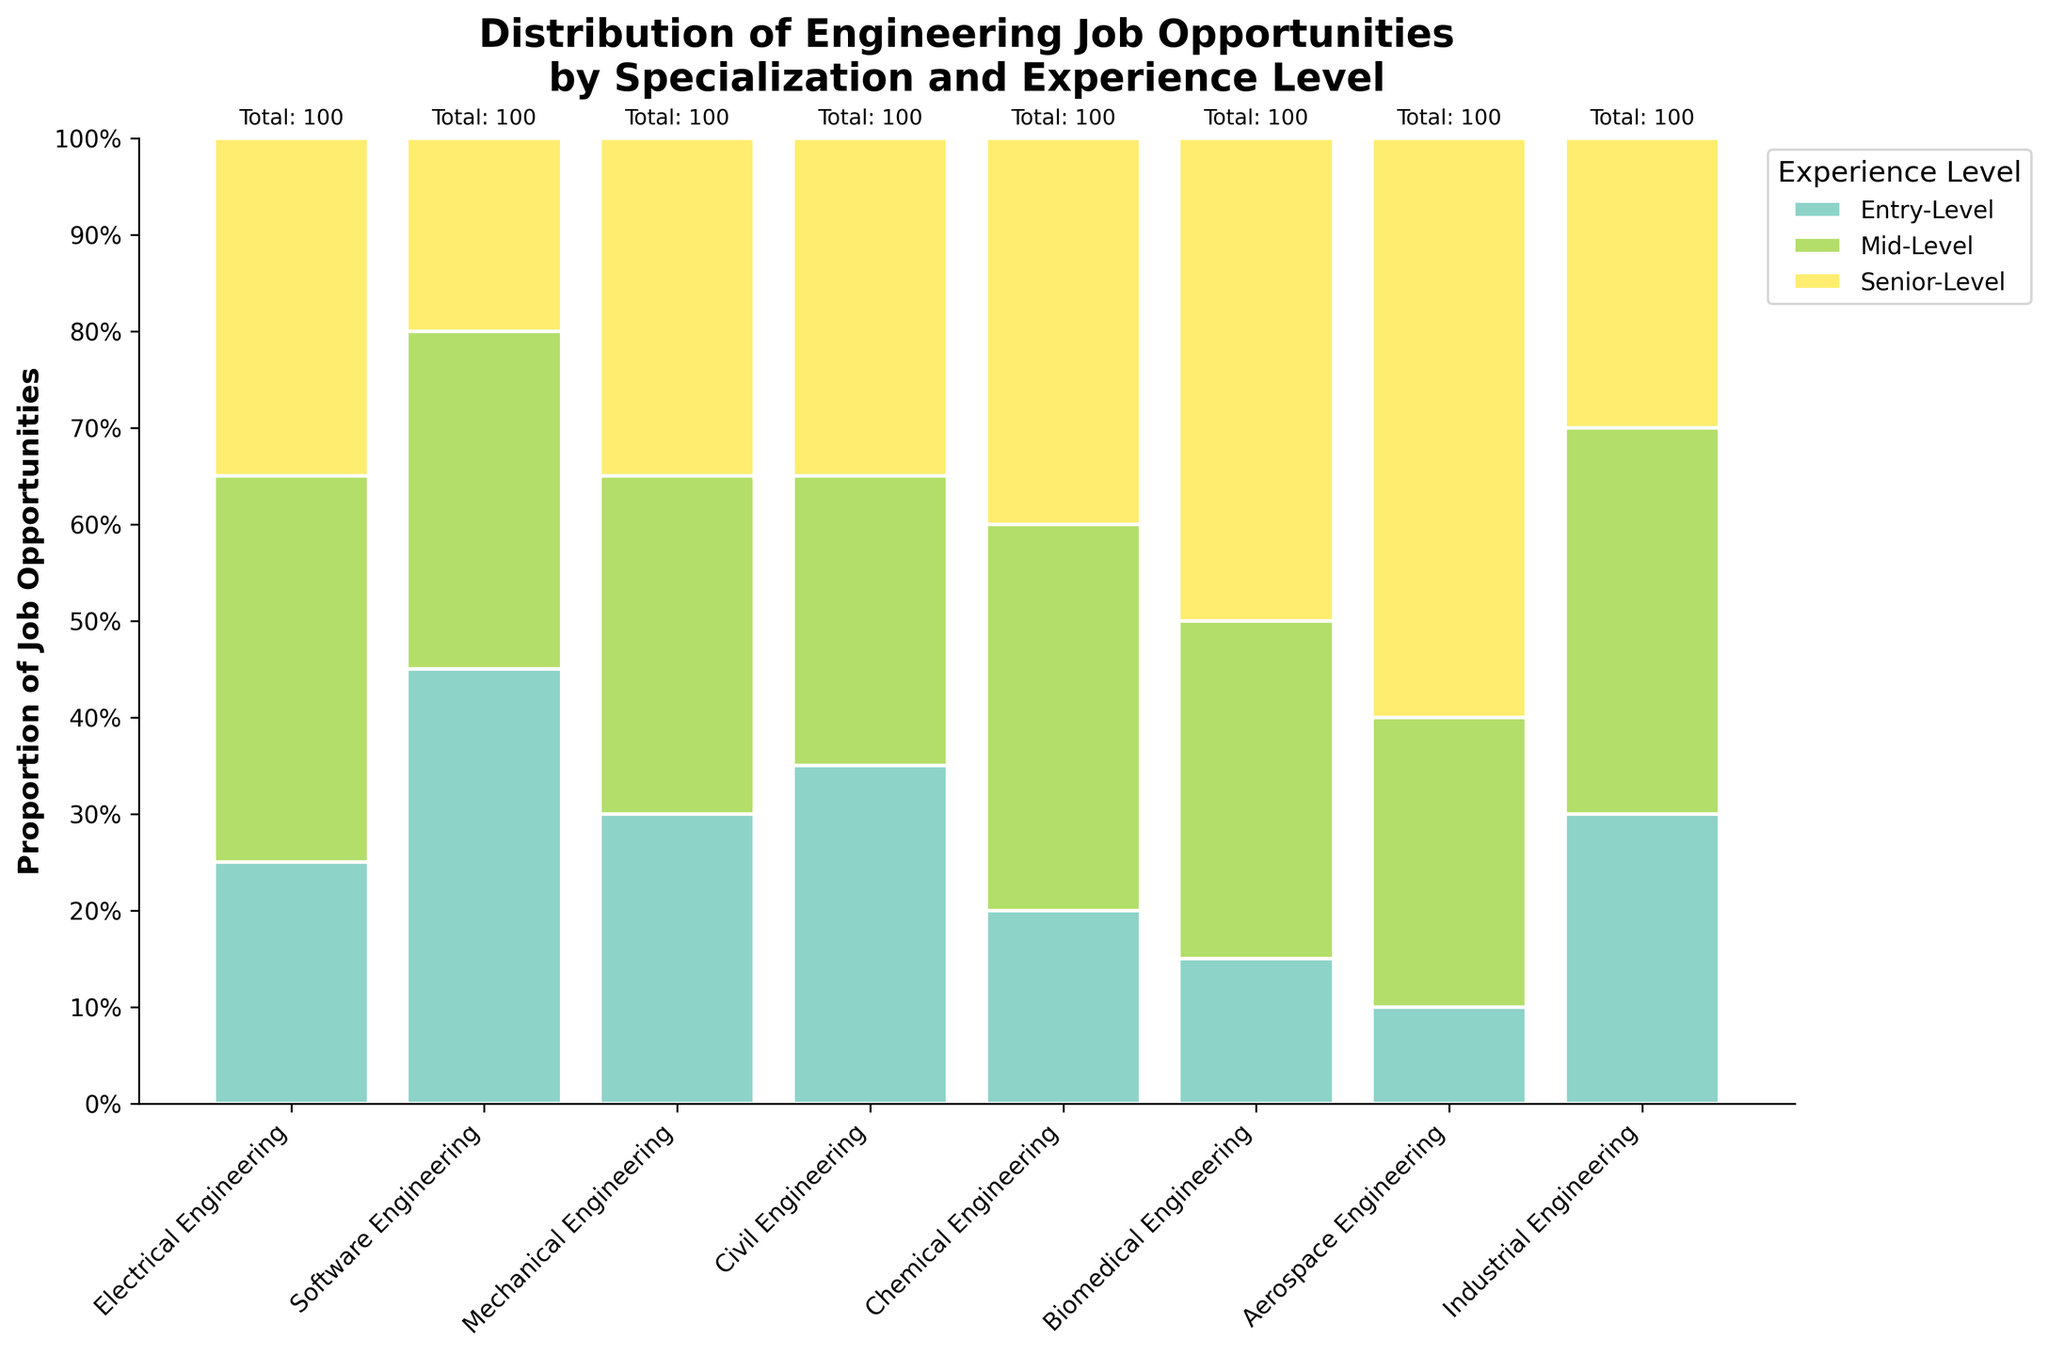What is the title of the figure? The title of a figure is usually located at the top. In this case, it says "Distribution of Engineering Job Opportunities by Specialization and Experience Level" in a large, bold font.
Answer: Distribution of Engineering Job Opportunities by Specialization and Experience Level What does the y-axis represent? The y-axis label is "Proportion of Job Opportunities," indicating that the vertical axis measures the proportion (percentage) of job opportunities based on specialization and experience level.
Answer: Proportion of Job Opportunities What is the total number of job opportunities for Software Engineering? The figure includes a label above the Software Engineering bar stating "Total: 100," which is the sum of entry-level (45), mid-level (35), and senior-level (20) job opportunities.
Answer: 100 Which specialization has the highest proportion of senior-level job opportunities? By looking at the height of the senior-level sections (the topmost segments) in each bar, Aerospace Engineering has the tallest section, indicating it has the highest proportion of senior-level job opportunities.
Answer: Aerospace Engineering How many more entry-level job opportunities are there in Software Engineering compared to Electrical Engineering? Software Engineering has 45 entry-level job opportunities while Electrical Engineering has 25. The difference is calculated as 45 - 25.
Answer: 20 Which specializations have an equal proportion of mid-level job opportunities? By visually comparing the heights of the middle sections (mid-level) in each bar, Electrical Engineering, Mechanical Engineering, Industrial Engineering, and Chemical Engineering all have the same proportion (0.4 or 40%).
Answer: Electrical Engineering, Mechanical Engineering, Industrial Engineering, Chemical Engineering What is the combined proportion of entry-level and mid-level job opportunities for Civil Engineering? The proportion of entry-level job opportunities for Civil Engineering is 35%, and the proportion for mid-level is 30%. Adding these, 35% + 30% gives the combined proportion.
Answer: 65% Which specialization has the lowest total number of job opportunities? Each bar has a label above stating the total number of job opportunities. Biomedical Engineering has the smallest total, which is 100 (sum of 15, 35, and 50).
Answer: Biomedical Engineering Compare the proportion of senior-level job opportunities in Mechanical Engineering and Industrial Engineering. Which one has a higher proportion? The senior-level proportions displayed in the top sections of the bars show that Mechanical Engineering and Industrial Engineering both have the same proportion at 35%, but Mechanical Engineering's bar segment appears higher due to visualization scaling.
Answer: Both are equal 